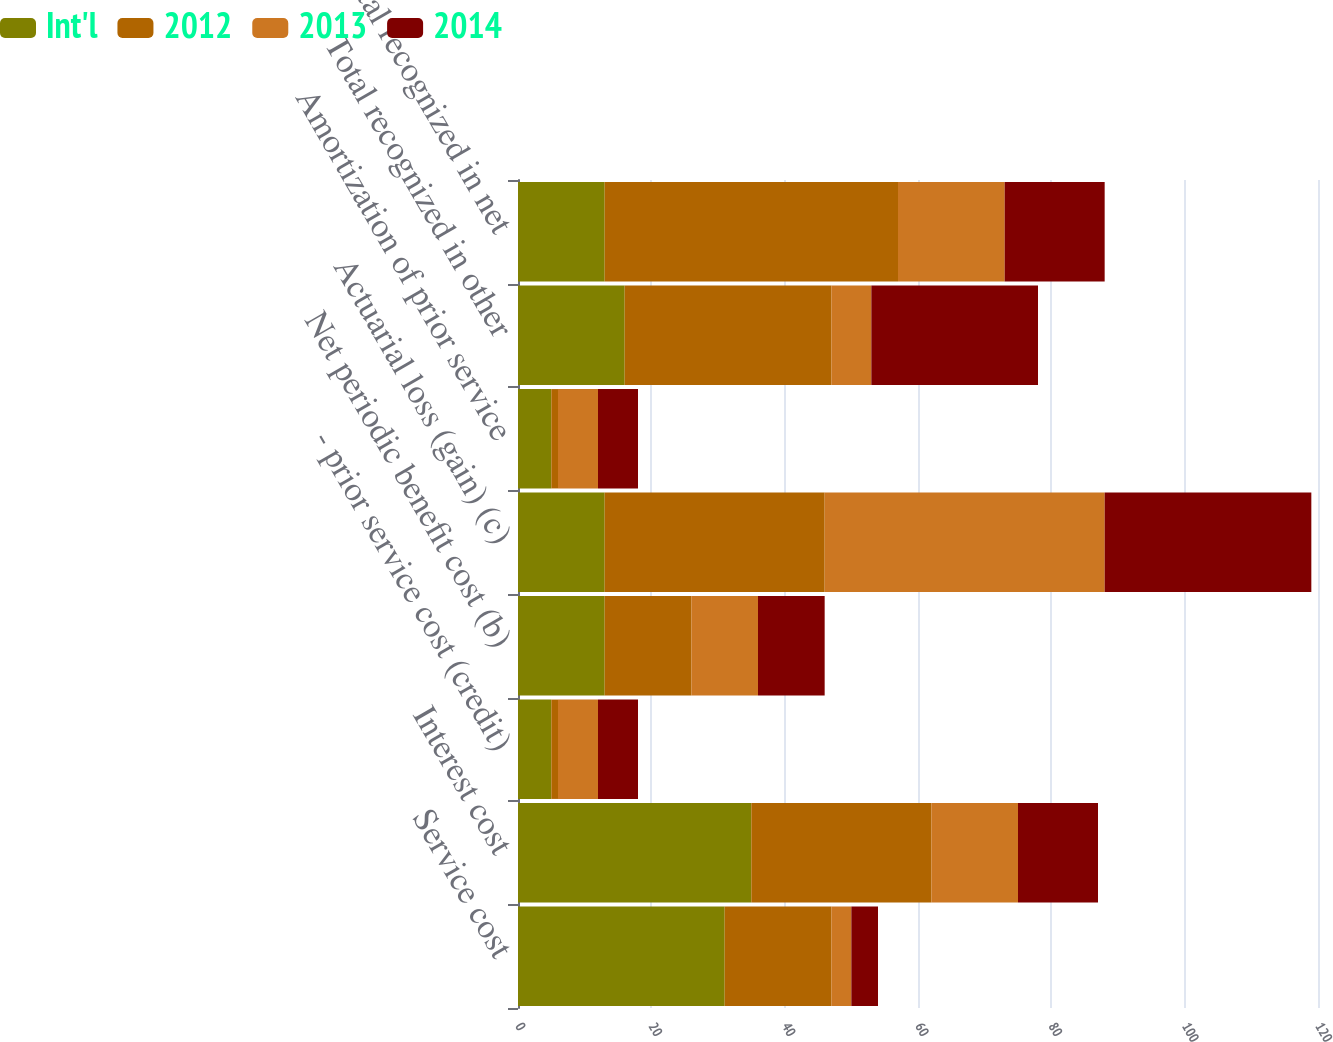Convert chart to OTSL. <chart><loc_0><loc_0><loc_500><loc_500><stacked_bar_chart><ecel><fcel>Service cost<fcel>Interest cost<fcel>- prior service cost (credit)<fcel>Net periodic benefit cost (b)<fcel>Actuarial loss (gain) (c)<fcel>Amortization of prior service<fcel>Total recognized in other<fcel>Total recognized in net<nl><fcel>Int'l<fcel>31<fcel>35<fcel>5<fcel>13<fcel>13<fcel>5<fcel>16<fcel>13<nl><fcel>2012<fcel>16<fcel>27<fcel>1<fcel>13<fcel>33<fcel>1<fcel>31<fcel>44<nl><fcel>2013<fcel>3<fcel>13<fcel>6<fcel>10<fcel>42<fcel>6<fcel>6<fcel>16<nl><fcel>2014<fcel>4<fcel>12<fcel>6<fcel>10<fcel>31<fcel>6<fcel>25<fcel>15<nl></chart> 